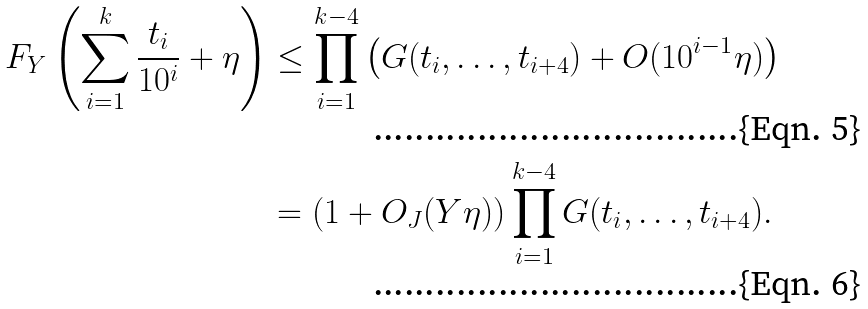<formula> <loc_0><loc_0><loc_500><loc_500>F _ { Y } \left ( \sum _ { i = 1 } ^ { k } \frac { t _ { i } } { 1 0 ^ { i } } + \eta \right ) & \leq \prod _ { i = 1 } ^ { k - 4 } \left ( G ( t _ { i } , \dots , t _ { i + 4 } ) + O ( 1 0 ^ { i - 1 } \eta ) \right ) \\ & = ( 1 + O _ { J } ( Y \eta ) ) \prod _ { i = 1 } ^ { k - 4 } G ( t _ { i } , \dots , t _ { i + 4 } ) .</formula> 